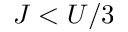<formula> <loc_0><loc_0><loc_500><loc_500>J < U / 3</formula> 